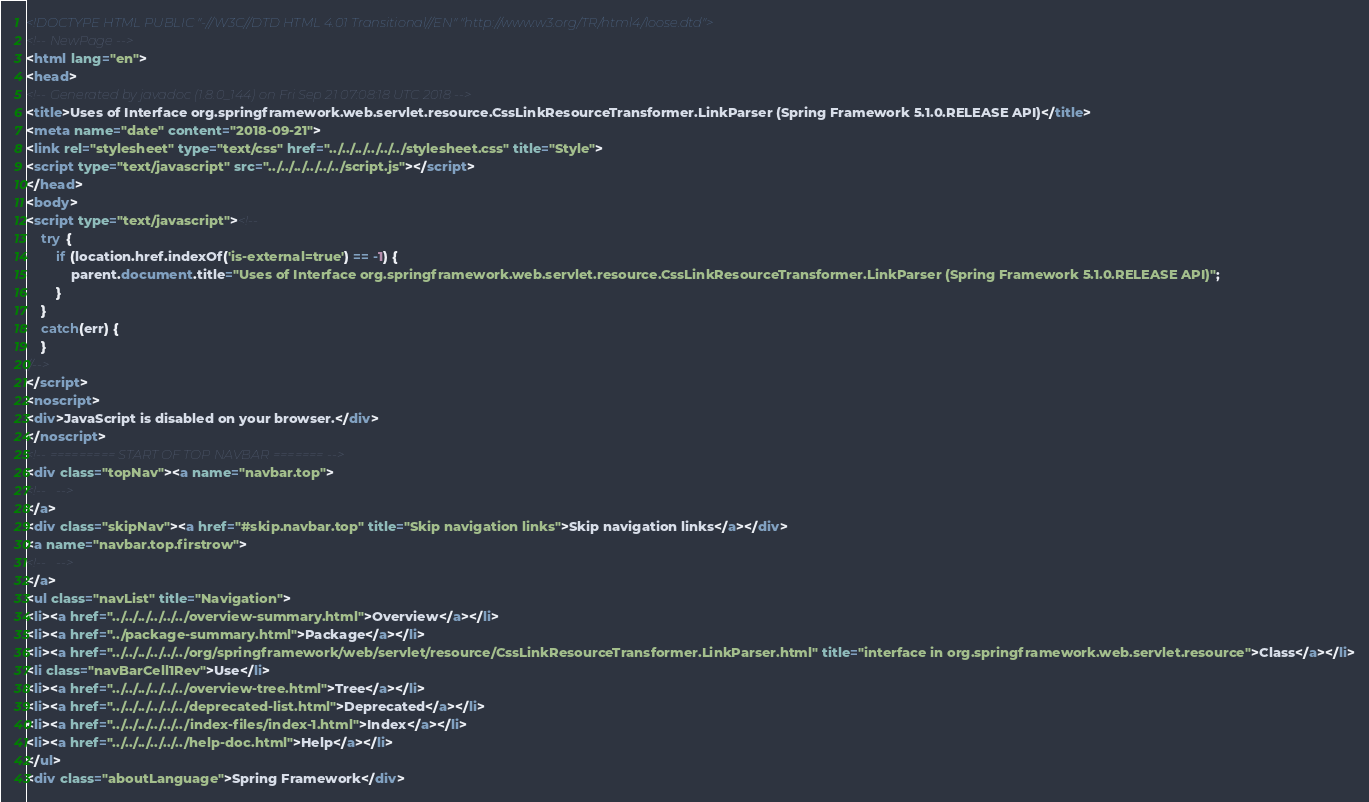Convert code to text. <code><loc_0><loc_0><loc_500><loc_500><_HTML_><!DOCTYPE HTML PUBLIC "-//W3C//DTD HTML 4.01 Transitional//EN" "http://www.w3.org/TR/html4/loose.dtd">
<!-- NewPage -->
<html lang="en">
<head>
<!-- Generated by javadoc (1.8.0_144) on Fri Sep 21 07:08:18 UTC 2018 -->
<title>Uses of Interface org.springframework.web.servlet.resource.CssLinkResourceTransformer.LinkParser (Spring Framework 5.1.0.RELEASE API)</title>
<meta name="date" content="2018-09-21">
<link rel="stylesheet" type="text/css" href="../../../../../../stylesheet.css" title="Style">
<script type="text/javascript" src="../../../../../../script.js"></script>
</head>
<body>
<script type="text/javascript"><!--
    try {
        if (location.href.indexOf('is-external=true') == -1) {
            parent.document.title="Uses of Interface org.springframework.web.servlet.resource.CssLinkResourceTransformer.LinkParser (Spring Framework 5.1.0.RELEASE API)";
        }
    }
    catch(err) {
    }
//-->
</script>
<noscript>
<div>JavaScript is disabled on your browser.</div>
</noscript>
<!-- ========= START OF TOP NAVBAR ======= -->
<div class="topNav"><a name="navbar.top">
<!--   -->
</a>
<div class="skipNav"><a href="#skip.navbar.top" title="Skip navigation links">Skip navigation links</a></div>
<a name="navbar.top.firstrow">
<!--   -->
</a>
<ul class="navList" title="Navigation">
<li><a href="../../../../../../overview-summary.html">Overview</a></li>
<li><a href="../package-summary.html">Package</a></li>
<li><a href="../../../../../../org/springframework/web/servlet/resource/CssLinkResourceTransformer.LinkParser.html" title="interface in org.springframework.web.servlet.resource">Class</a></li>
<li class="navBarCell1Rev">Use</li>
<li><a href="../../../../../../overview-tree.html">Tree</a></li>
<li><a href="../../../../../../deprecated-list.html">Deprecated</a></li>
<li><a href="../../../../../../index-files/index-1.html">Index</a></li>
<li><a href="../../../../../../help-doc.html">Help</a></li>
</ul>
<div class="aboutLanguage">Spring Framework</div></code> 